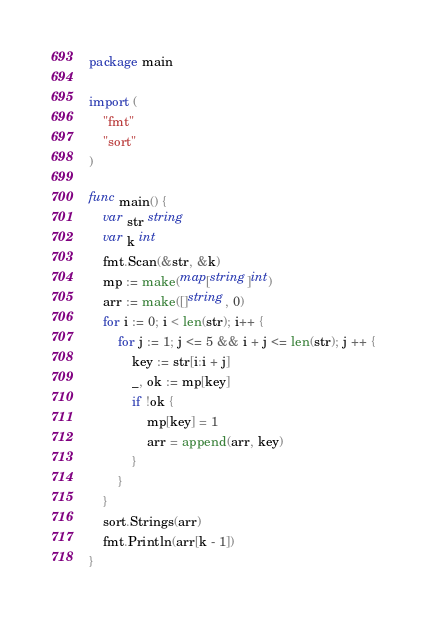<code> <loc_0><loc_0><loc_500><loc_500><_Go_>package main

import (
	"fmt"
	"sort"
)

func main() {
	var str string
	var k int
	fmt.Scan(&str, &k)
	mp := make(map[string]int)
	arr := make([]string, 0)
	for i := 0; i < len(str); i++ {
		for j := 1; j <= 5 && i + j <= len(str); j ++ {
			key := str[i:i + j]
			_, ok := mp[key]
			if !ok {
				mp[key] = 1
				arr = append(arr, key)
			}
		}
	}
	sort.Strings(arr)
	fmt.Println(arr[k - 1])
}</code> 